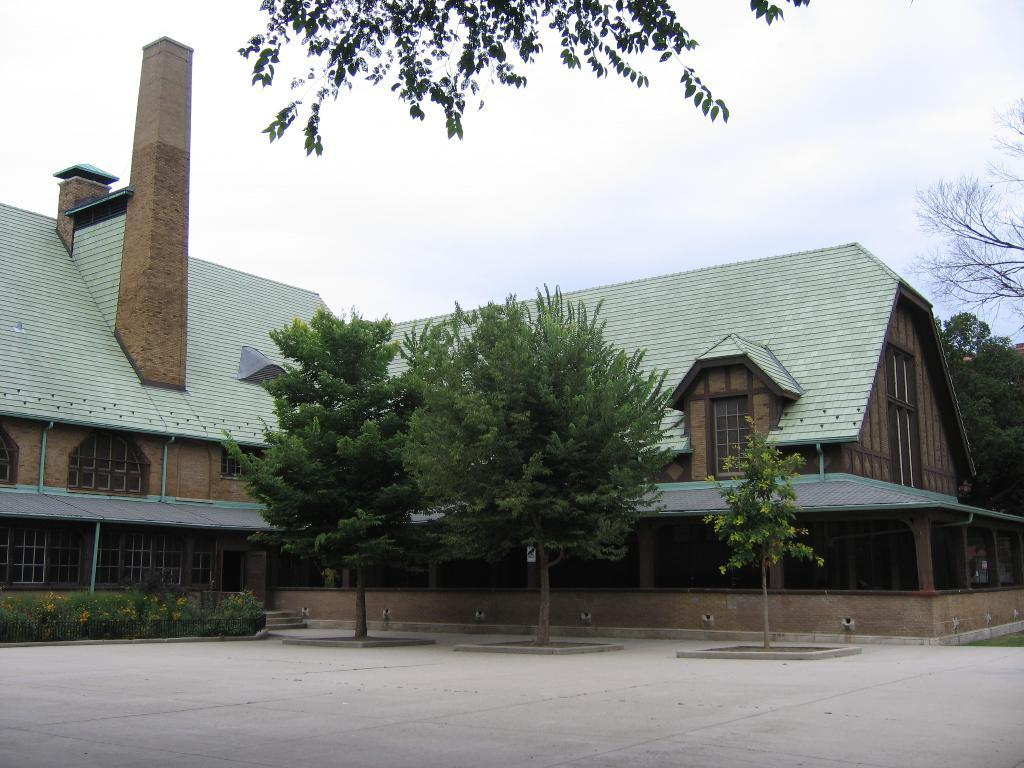What type of structure is present in the image? There is a house in the image. What feature of the house is mentioned in the facts? The house has windows. What other natural elements can be seen in the image? There are plants and trees in the image. What is visible in the sky in the image? Clouds are visible in the sky. What type of wound can be seen on the tree in the image? There is no wound present on any tree in the image. Is there a hose visible in the image? There is no hose mentioned in the provided facts, so it cannot be determined if one is present in the image. 